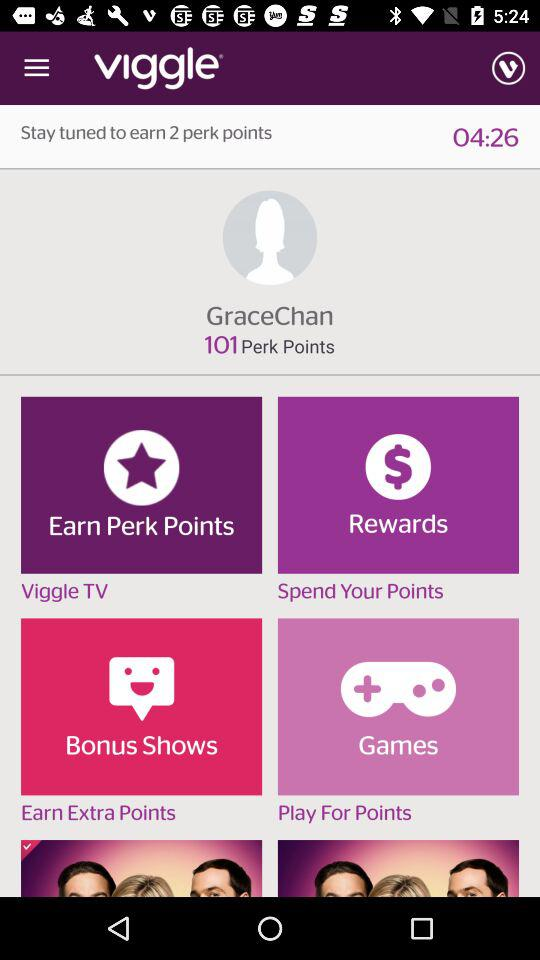How many Perk Points are there in balance? There are 101 Perk Points in balance. 